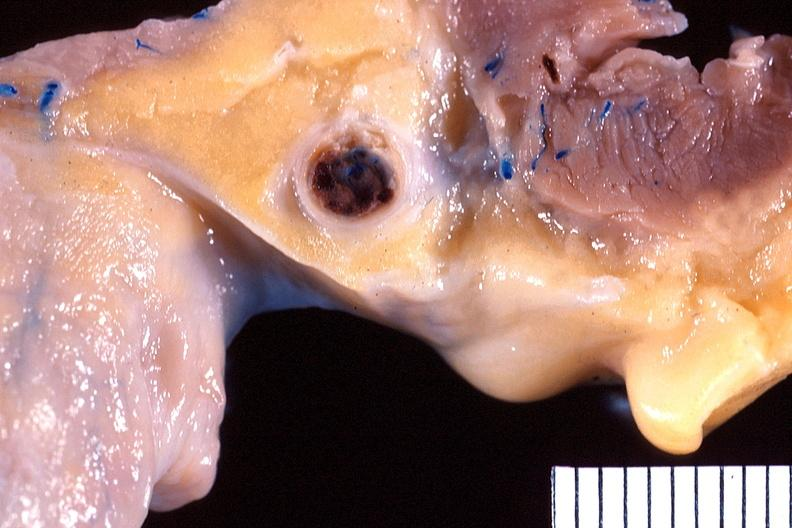does this image show heart, right coronary artery, atherosclerosis and acute thrombus?
Answer the question using a single word or phrase. Yes 